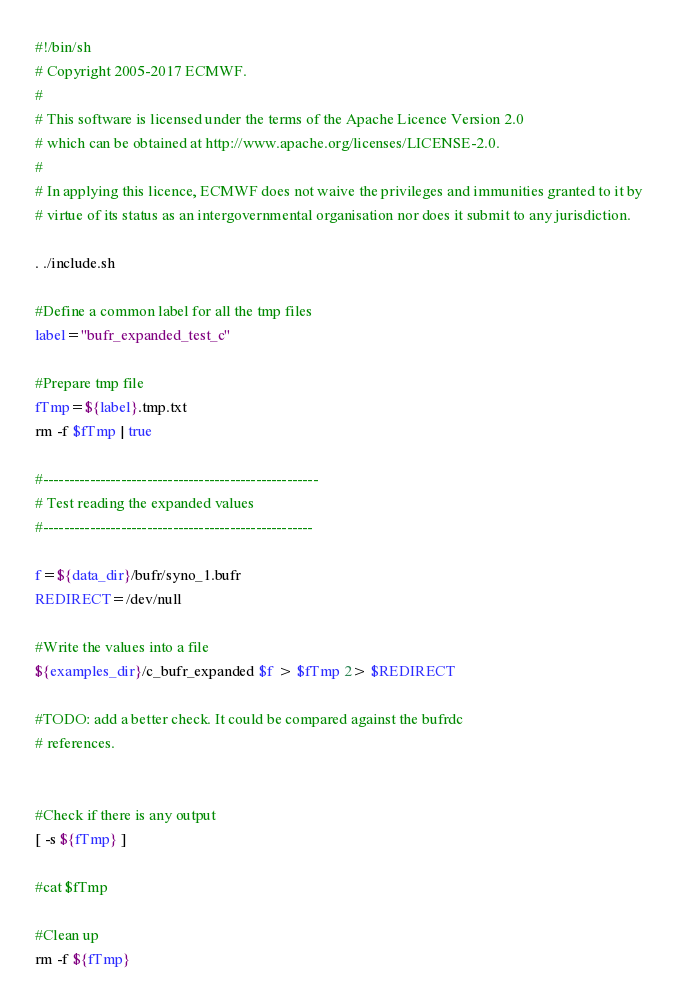Convert code to text. <code><loc_0><loc_0><loc_500><loc_500><_Bash_>#!/bin/sh
# Copyright 2005-2017 ECMWF.
#
# This software is licensed under the terms of the Apache Licence Version 2.0
# which can be obtained at http://www.apache.org/licenses/LICENSE-2.0.
#
# In applying this licence, ECMWF does not waive the privileges and immunities granted to it by
# virtue of its status as an intergovernmental organisation nor does it submit to any jurisdiction.

. ./include.sh

#Define a common label for all the tmp files
label="bufr_expanded_test_c"

#Prepare tmp file
fTmp=${label}.tmp.txt
rm -f $fTmp | true

#-----------------------------------------------------
# Test reading the expanded values
#----------------------------------------------------
  
f=${data_dir}/bufr/syno_1.bufr
REDIRECT=/dev/null

#Write the values into a file
${examples_dir}/c_bufr_expanded $f > $fTmp 2> $REDIRECT

#TODO: add a better check. It could be compared against the bufrdc
# references.


#Check if there is any output
[ -s ${fTmp} ]

#cat $fTmp 

#Clean up
rm -f ${fTmp}
</code> 